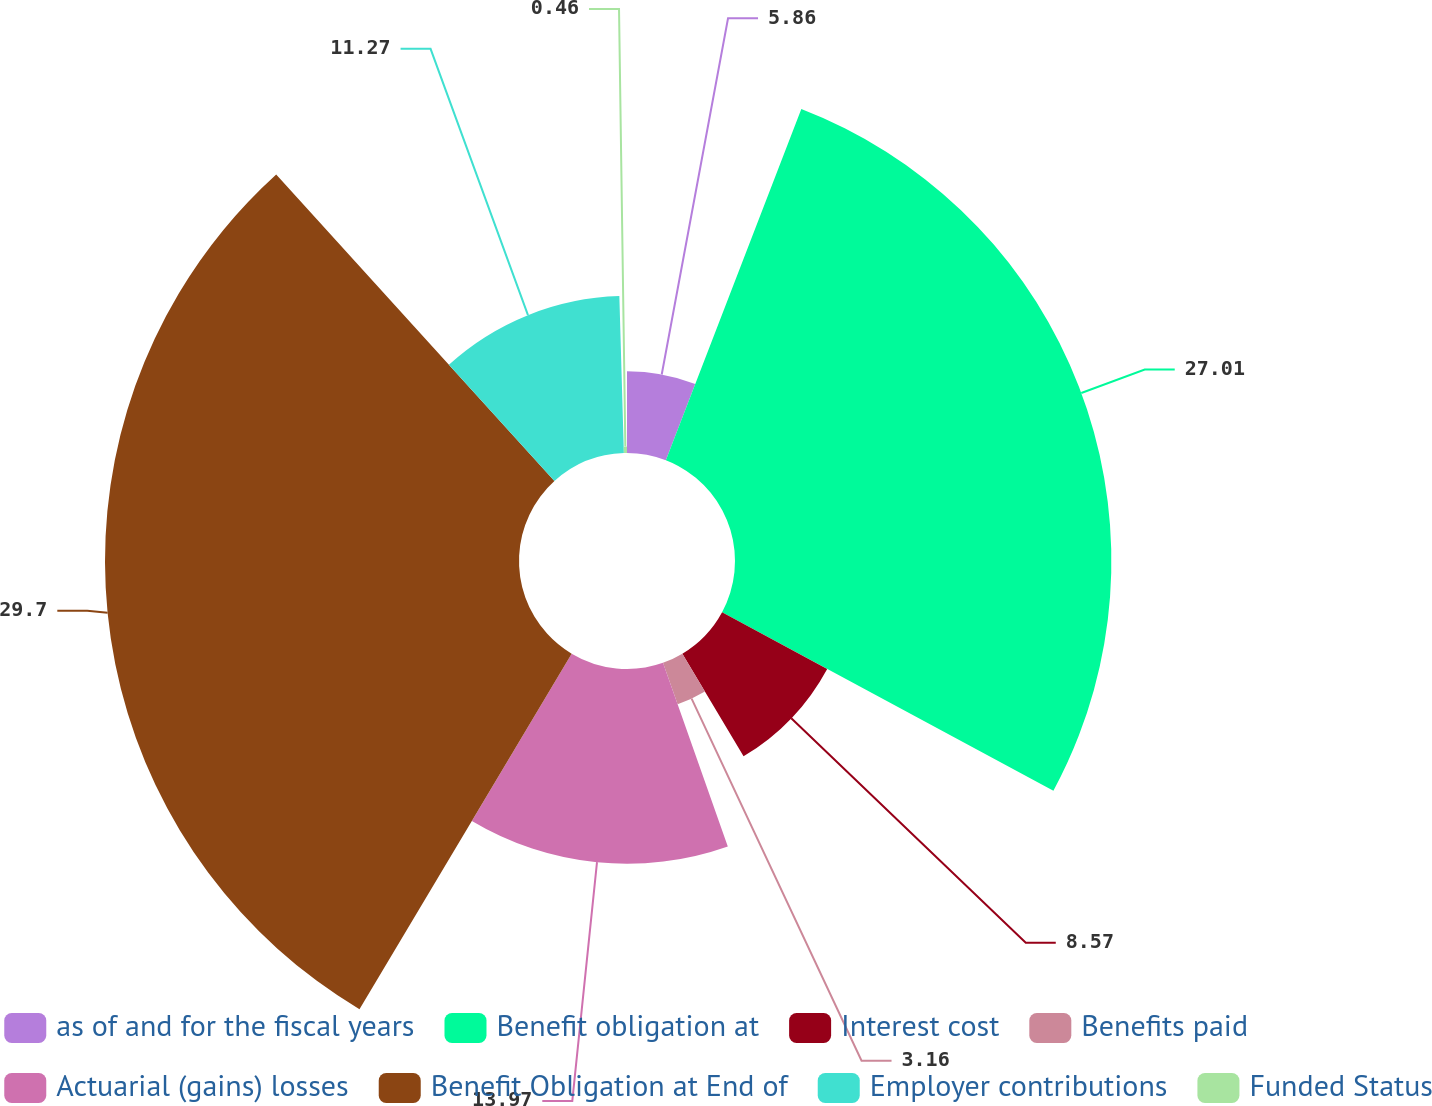<chart> <loc_0><loc_0><loc_500><loc_500><pie_chart><fcel>as of and for the fiscal years<fcel>Benefit obligation at<fcel>Interest cost<fcel>Benefits paid<fcel>Actuarial (gains) losses<fcel>Benefit Obligation at End of<fcel>Employer contributions<fcel>Funded Status<nl><fcel>5.86%<fcel>27.01%<fcel>8.57%<fcel>3.16%<fcel>13.97%<fcel>29.71%<fcel>11.27%<fcel>0.46%<nl></chart> 